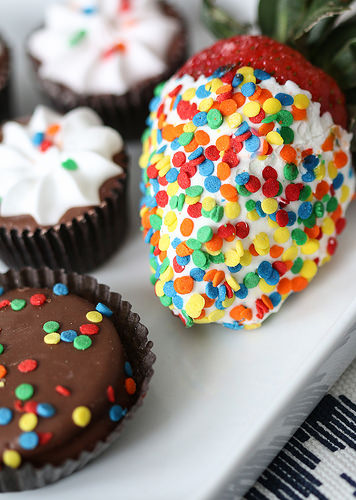<image>
Is there a strawberry on the table? Yes. Looking at the image, I can see the strawberry is positioned on top of the table, with the table providing support. 